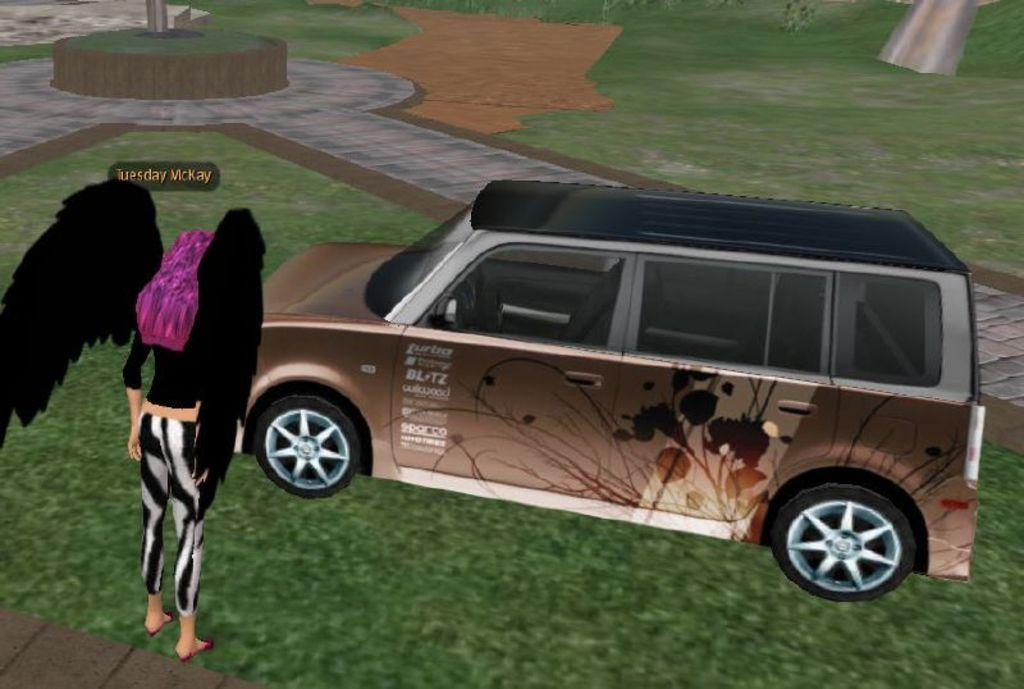What type of image is being described? The image is an animated picture. What can be seen on the grassland in the image? There is a vehicle and a woman with wings standing on the grassland. Are there any structures or objects on the path in the image? Yes, there is a pole on the path. How does the woman with wings create a dust storm in the image? There is no dust storm present in the image, and the woman with wings does not create one. 